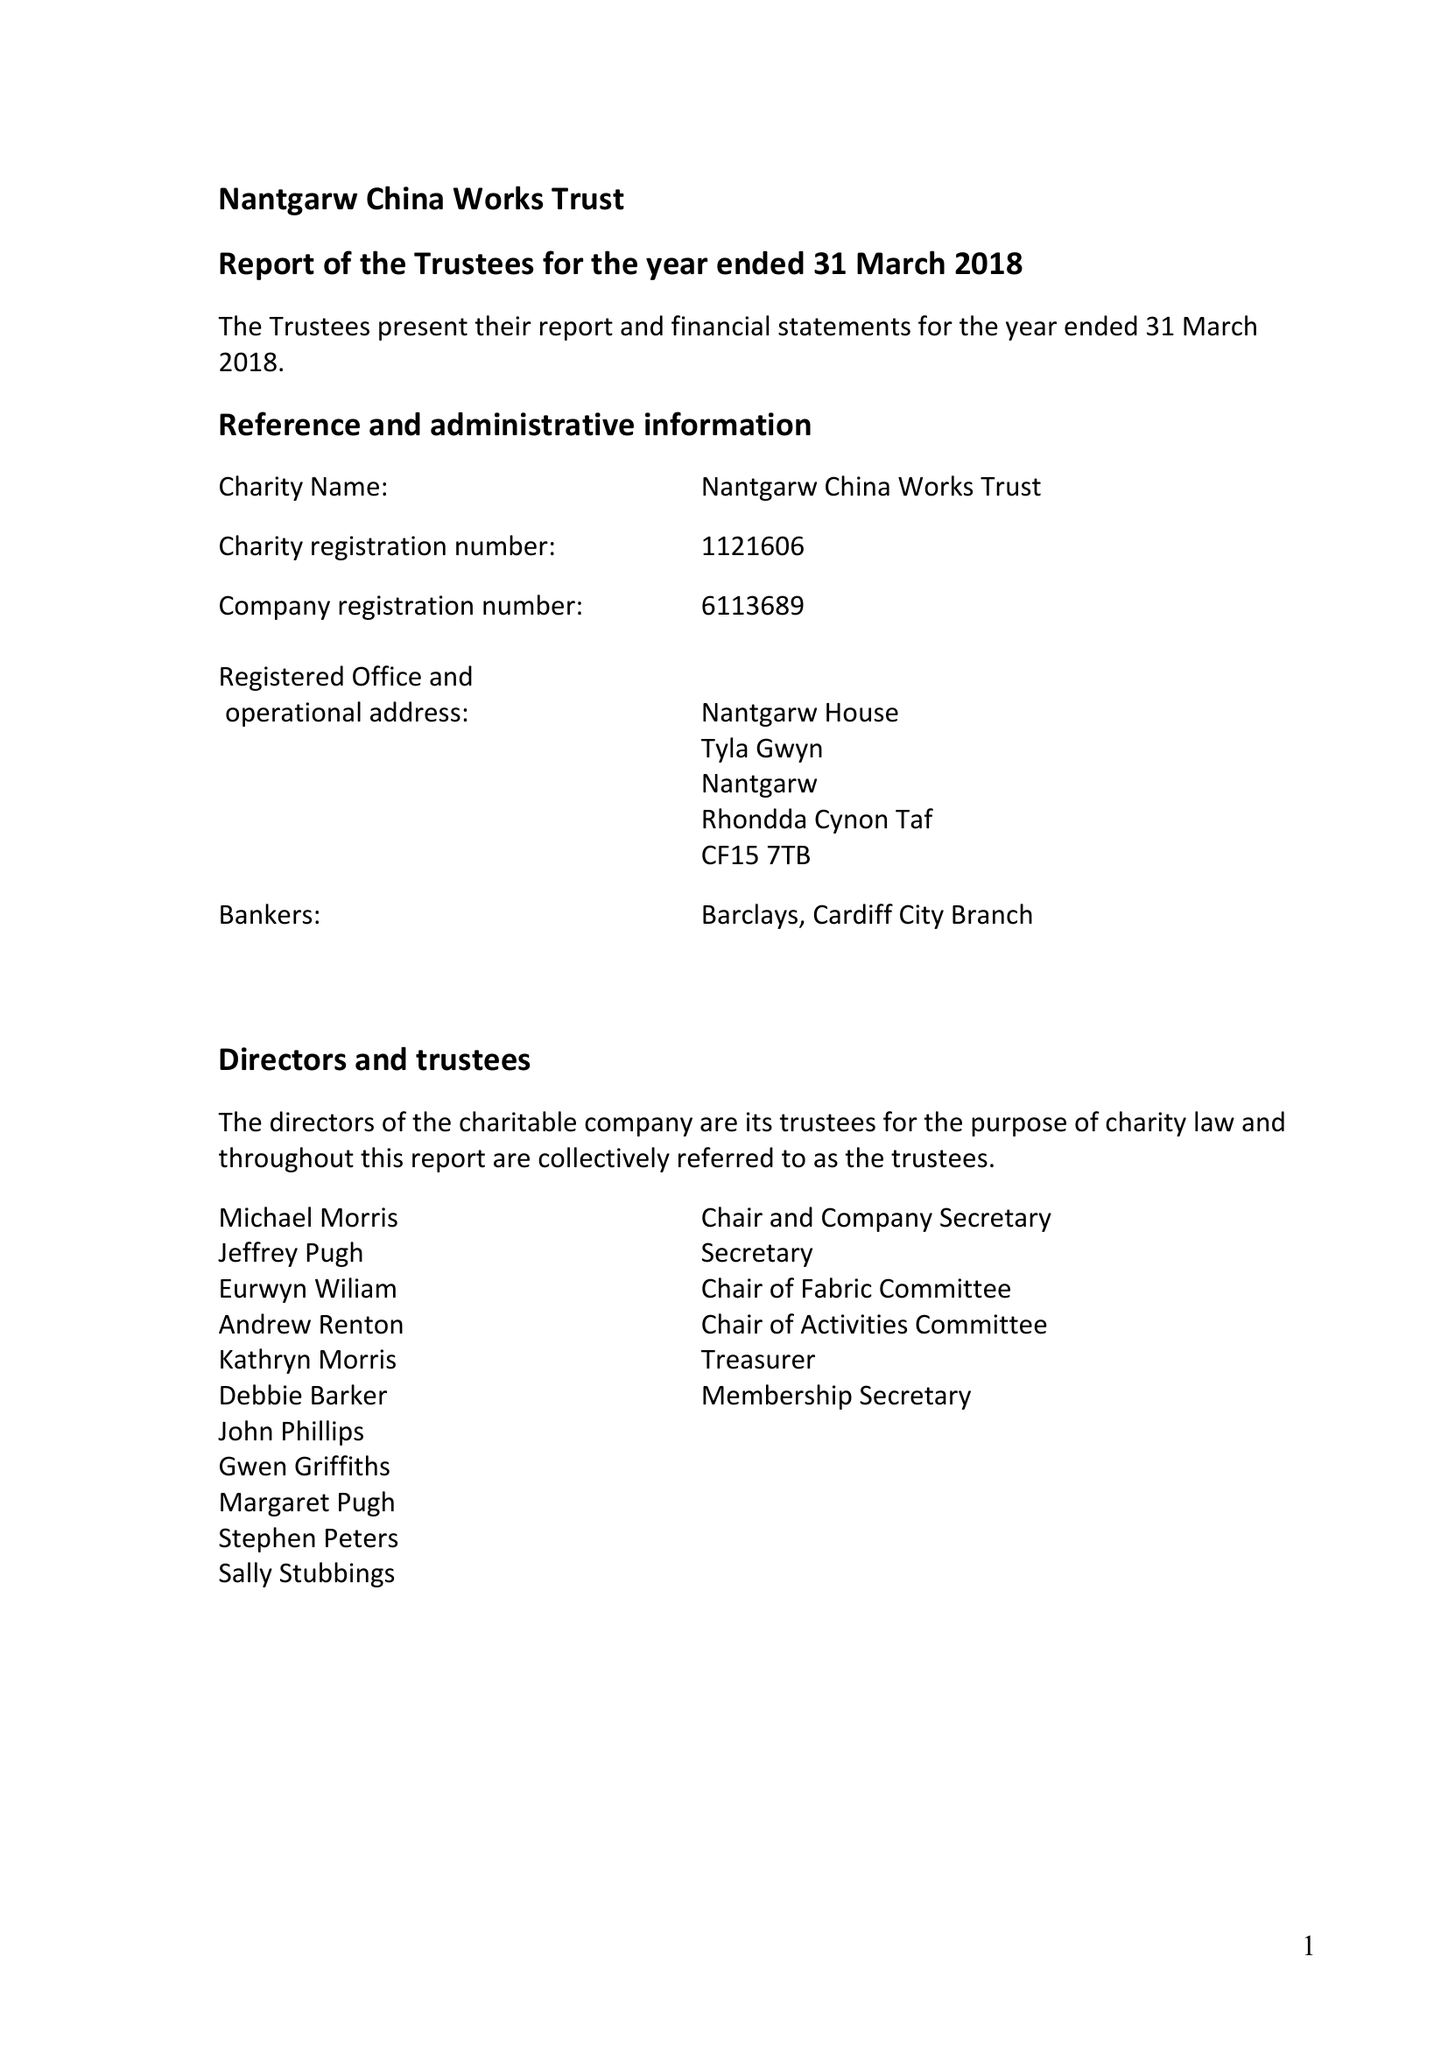What is the value for the report_date?
Answer the question using a single word or phrase. 2018-03-31 